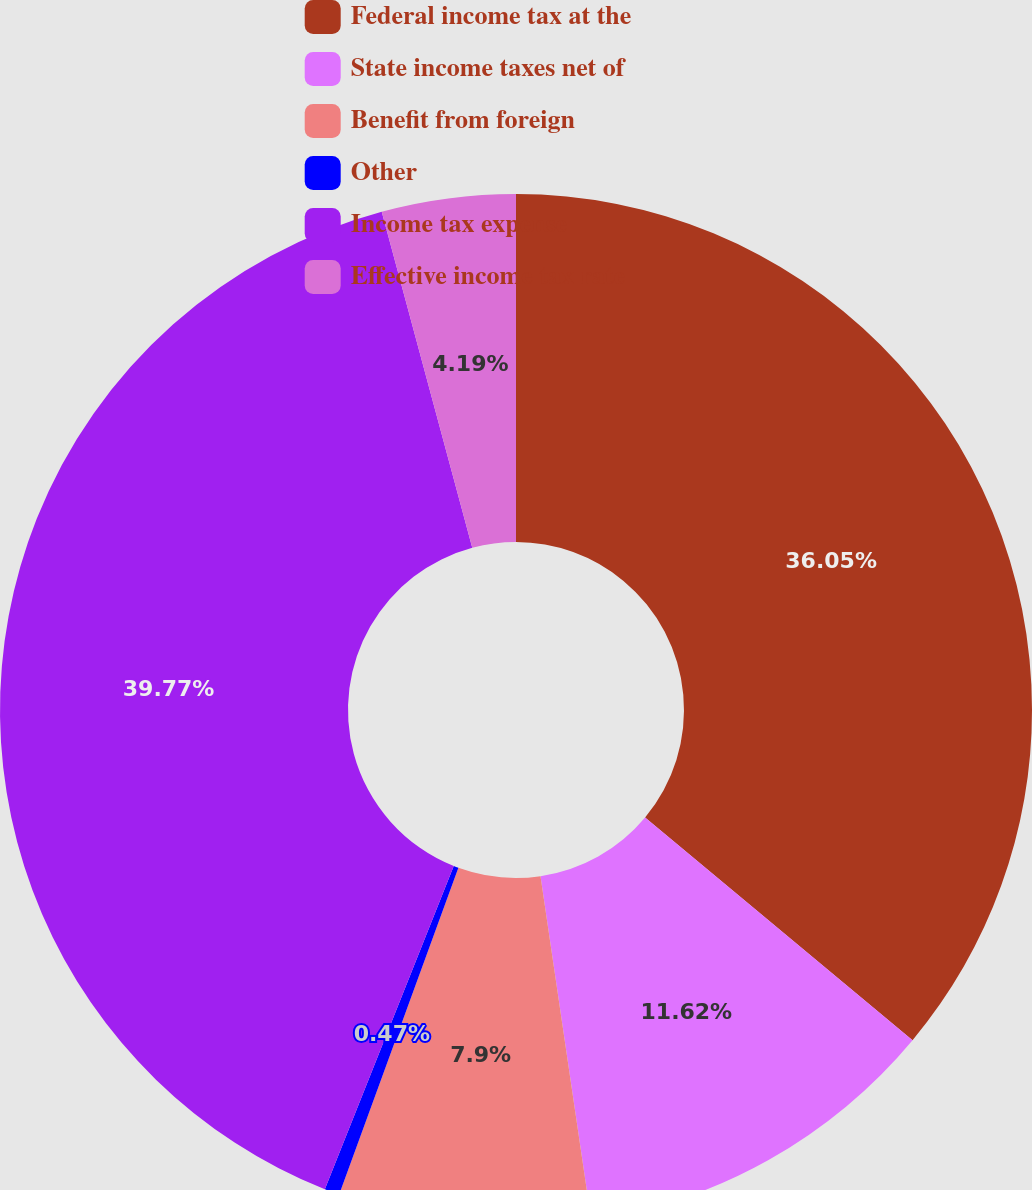<chart> <loc_0><loc_0><loc_500><loc_500><pie_chart><fcel>Federal income tax at the<fcel>State income taxes net of<fcel>Benefit from foreign<fcel>Other<fcel>Income tax expense<fcel>Effective income tax rate<nl><fcel>36.05%<fcel>11.62%<fcel>7.9%<fcel>0.47%<fcel>39.77%<fcel>4.19%<nl></chart> 